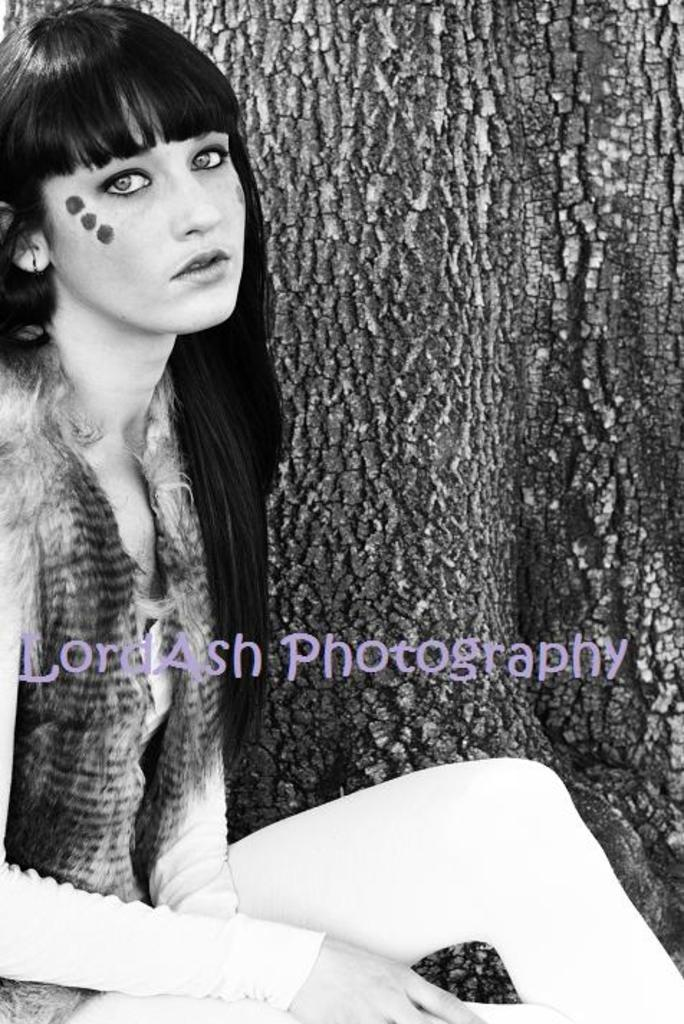Who is present in the image? There is a woman in the image. What natural element can be seen in the image? There is tree bark in the image. What type of string is being used to measure the angle of the tree in the image? There is no string or angle measurement present in the image; it only features a woman and tree bark. 